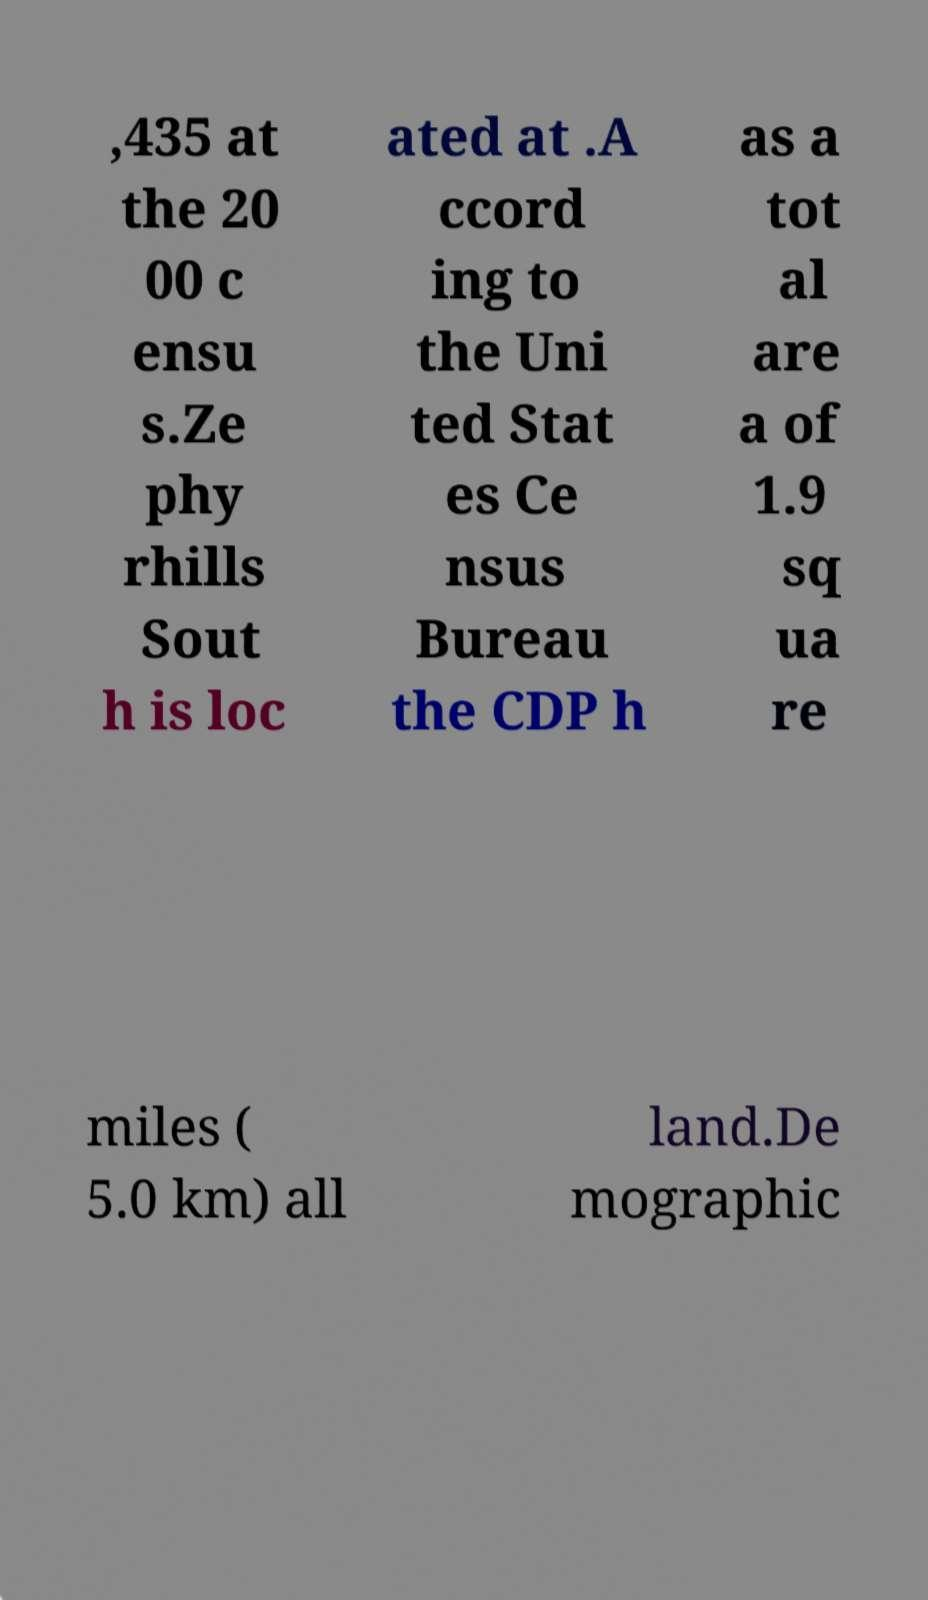I need the written content from this picture converted into text. Can you do that? ,435 at the 20 00 c ensu s.Ze phy rhills Sout h is loc ated at .A ccord ing to the Uni ted Stat es Ce nsus Bureau the CDP h as a tot al are a of 1.9 sq ua re miles ( 5.0 km) all land.De mographic 